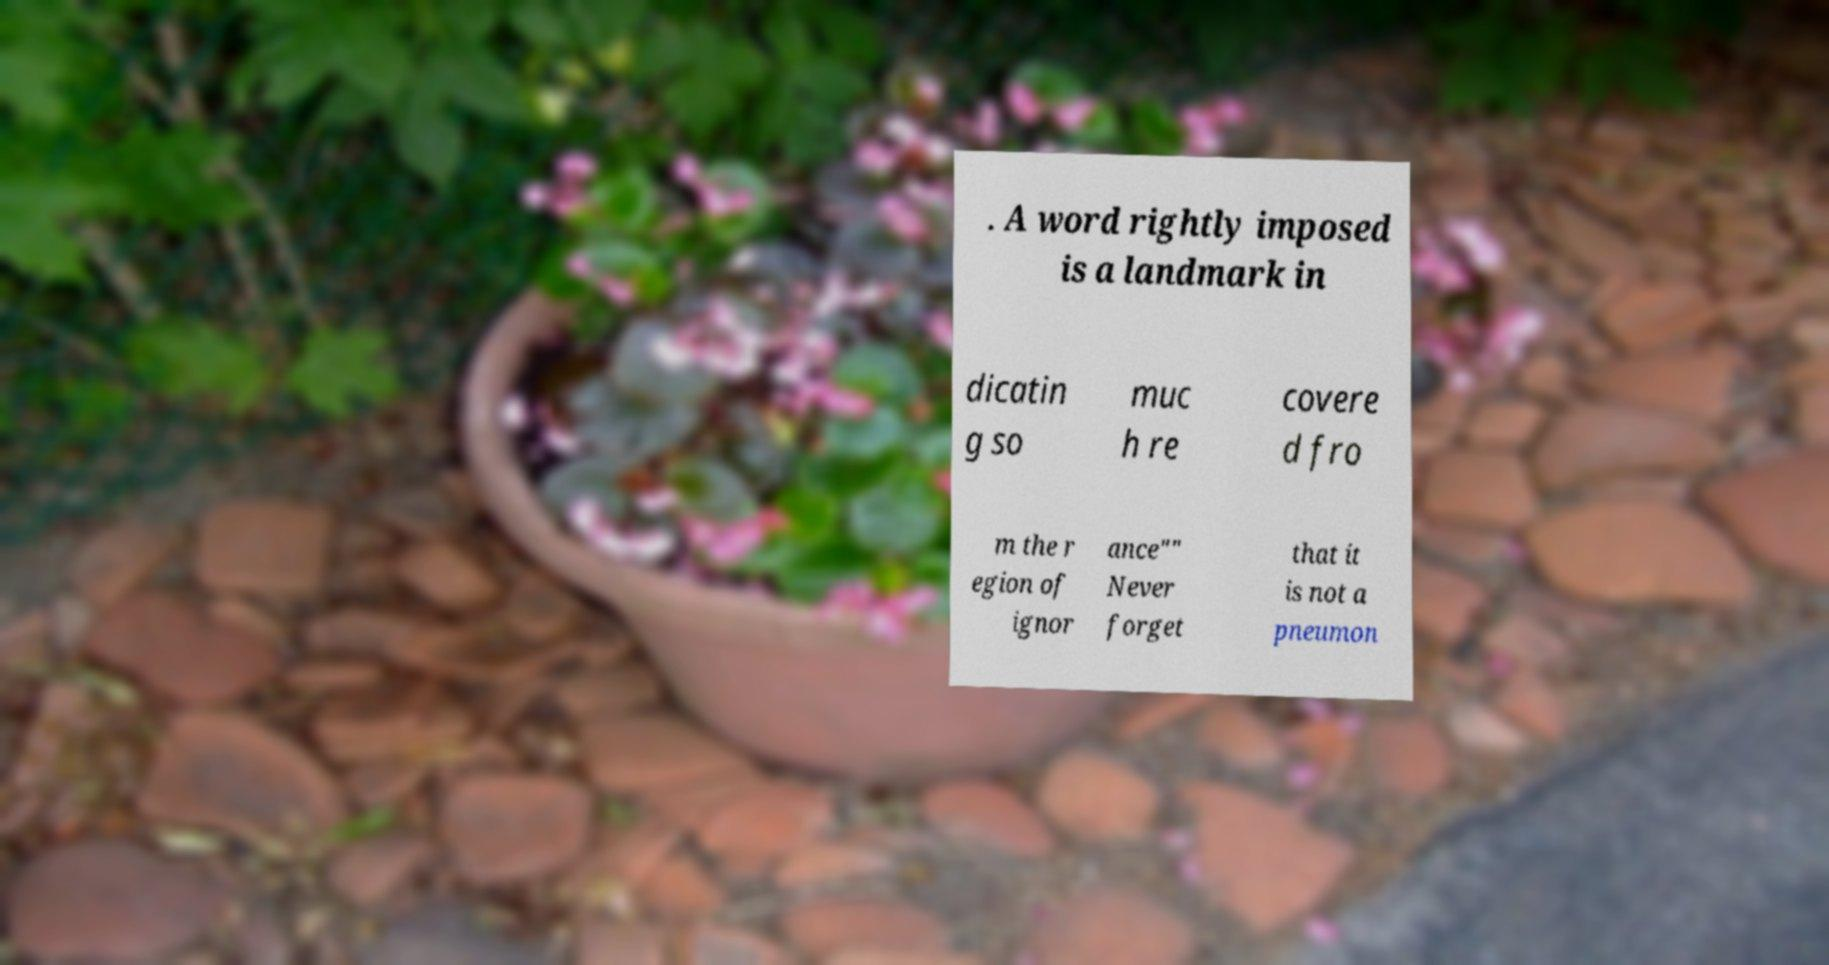There's text embedded in this image that I need extracted. Can you transcribe it verbatim? . A word rightly imposed is a landmark in dicatin g so muc h re covere d fro m the r egion of ignor ance"" Never forget that it is not a pneumon 